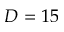Convert formula to latex. <formula><loc_0><loc_0><loc_500><loc_500>D = 1 5</formula> 